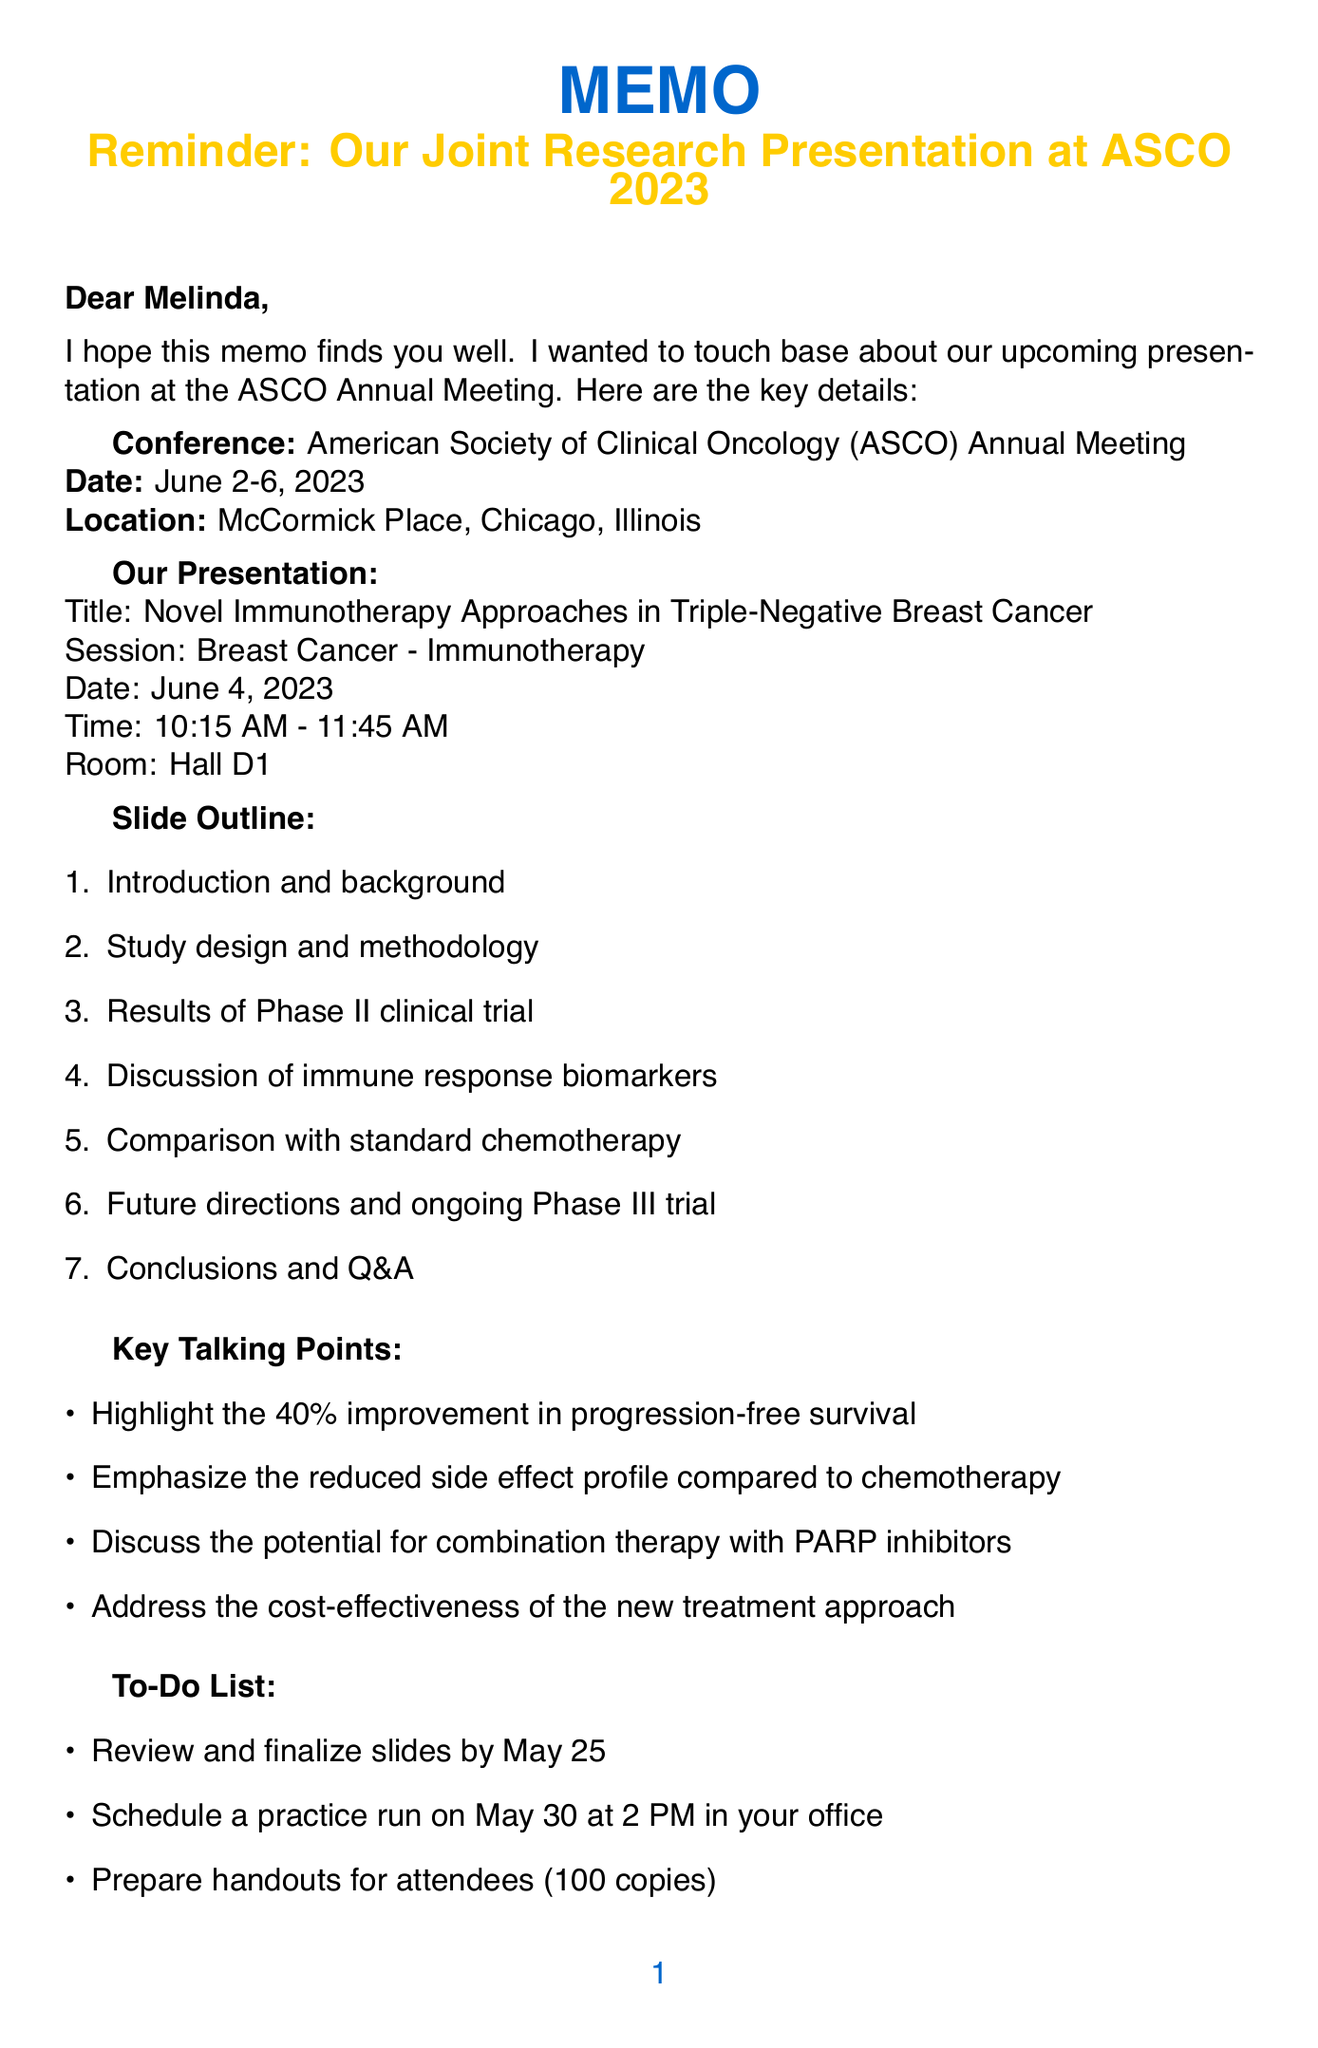What is the title of the presentation? The title of the presentation is explicitly stated in the document as "Novel Immunotherapy Approaches in Triple-Negative Breast Cancer."
Answer: Novel Immunotherapy Approaches in Triple-Negative Breast Cancer When is the presentation scheduled? The date of the presentation is mentioned in the document as June 4, 2023.
Answer: June 4, 2023 What room will the presentation take place in? The document specifies that the presentation will be held in Hall D1.
Answer: Hall D1 What is one key talking point regarding side effects? The memo highlights a reduced side effect profile compared to chemotherapy as one of the key talking points.
Answer: Reduced side effect profile compared to chemotherapy What are the travel arrangements? The memo states that flights have been booked and they leave on June 1 at 2 PM from Boston Logan.
Answer: June 1 at 2 PM from Boston Logan What is the deadline to finalize the slides? The memo clearly states the deadline for finalizing slides is May 25.
Answer: May 25 What social event is mentioned in the personal notes? The document includes a note about the ASCO Women in Oncology dinner on June 3 at 7 PM.
Answer: ASCO Women in Oncology dinner on June 3 at 7 PM What is included in the slide outline? The slide outline consists of seven sections as detailed in the document.
Answer: Introduction and background, Study design and methodology, Results of Phase II clinical trial, Discussion of immune response biomarkers, Comparison with standard chemotherapy, Future directions and ongoing Phase III trial, Conclusions and Q&A What is a reason for addressing cost-effectiveness? Addressing the cost-effectiveness of the new treatment approach is one of the key talking points in the memo.
Answer: Cost-effectiveness of the new treatment approach 